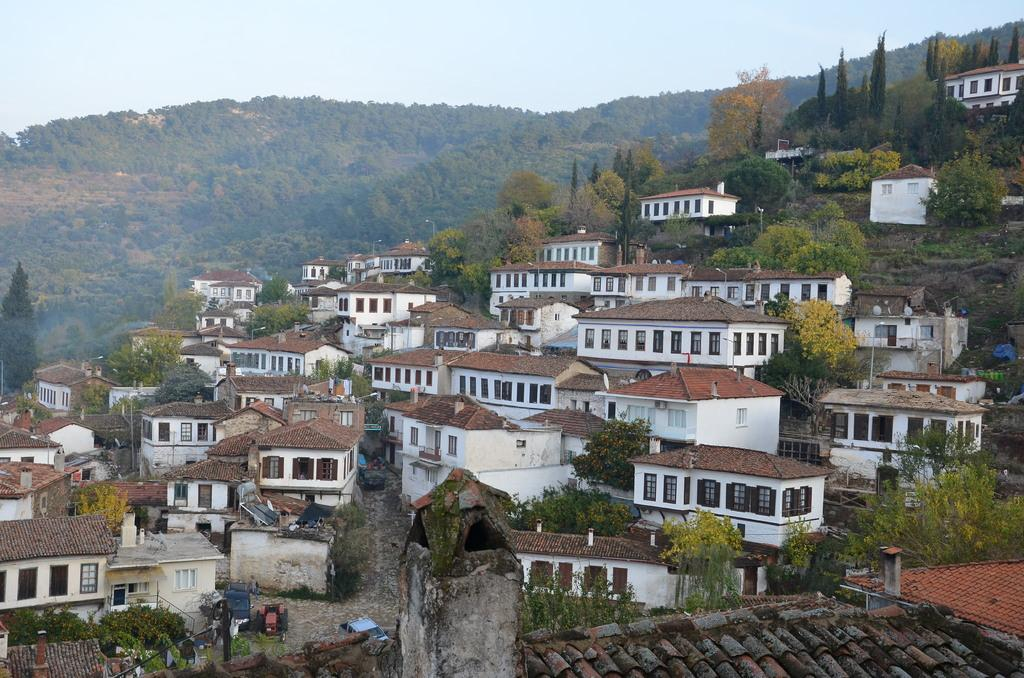What type of structures can be seen in the image? There are buildings in the image. What other natural elements are present in the image? There are trees in the image. What are the tall, thin objects in the image? There are poles in the image. What can be seen in the distance in the image? There is a hill visible in the background of the image. What is visible above the buildings and trees in the image? The sky is visible in the background of the image. How many hands are visible in the image? There are no hands visible in the image. What type of plot is being used for the buildings in the image? The image does not provide information about the type of plot used for the buildings. 